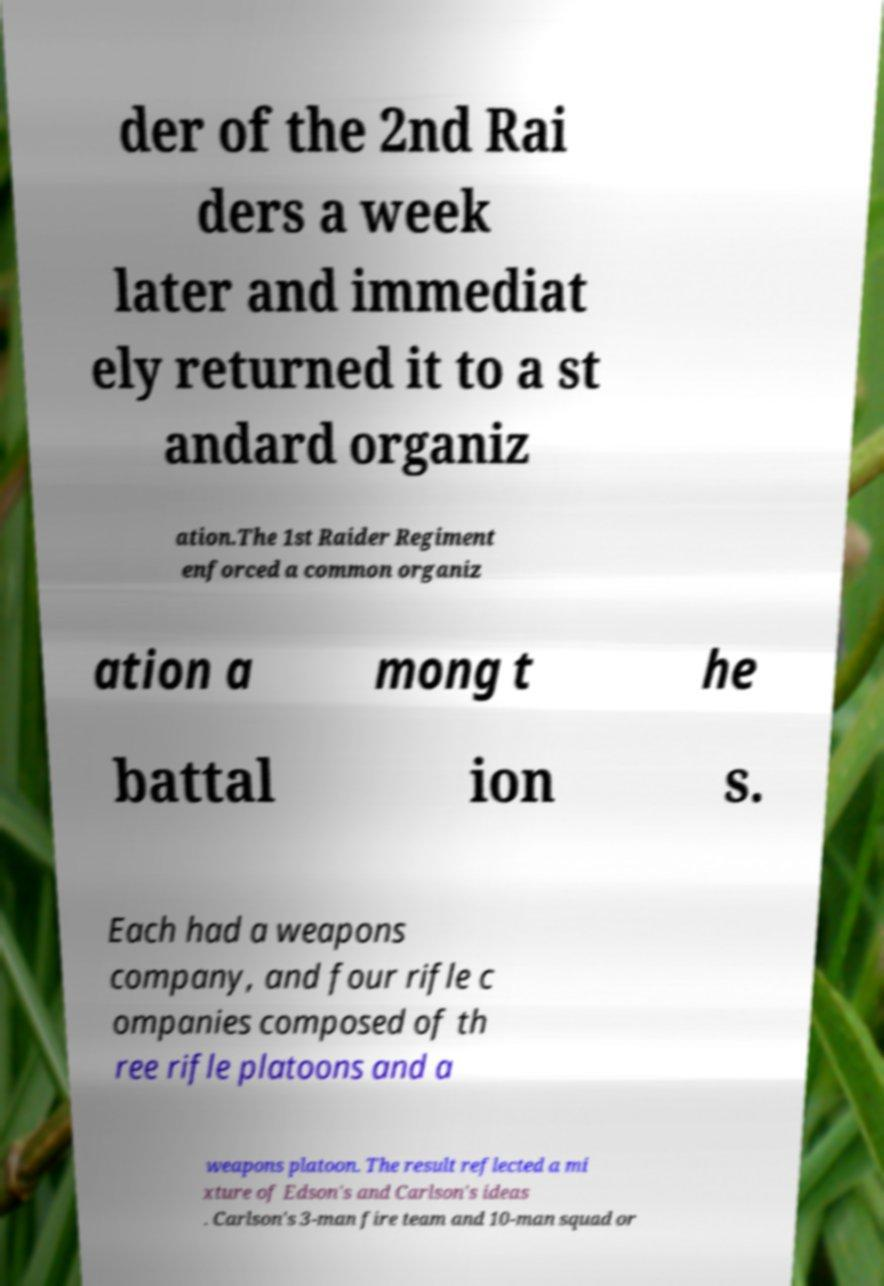Please identify and transcribe the text found in this image. der of the 2nd Rai ders a week later and immediat ely returned it to a st andard organiz ation.The 1st Raider Regiment enforced a common organiz ation a mong t he battal ion s. Each had a weapons company, and four rifle c ompanies composed of th ree rifle platoons and a weapons platoon. The result reflected a mi xture of Edson's and Carlson's ideas . Carlson's 3-man fire team and 10-man squad or 